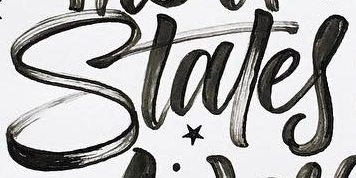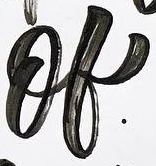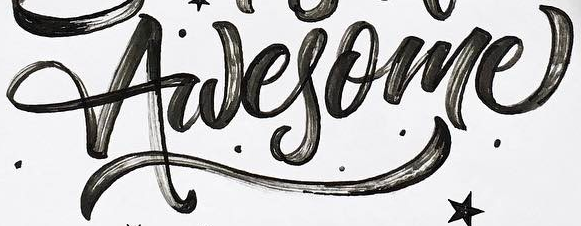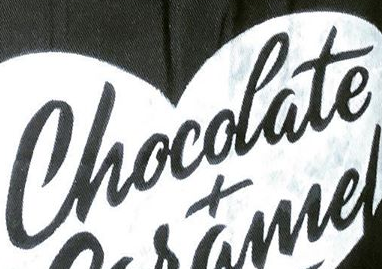Transcribe the words shown in these images in order, separated by a semicolon. Stales; of; Awesome; Chocolate 